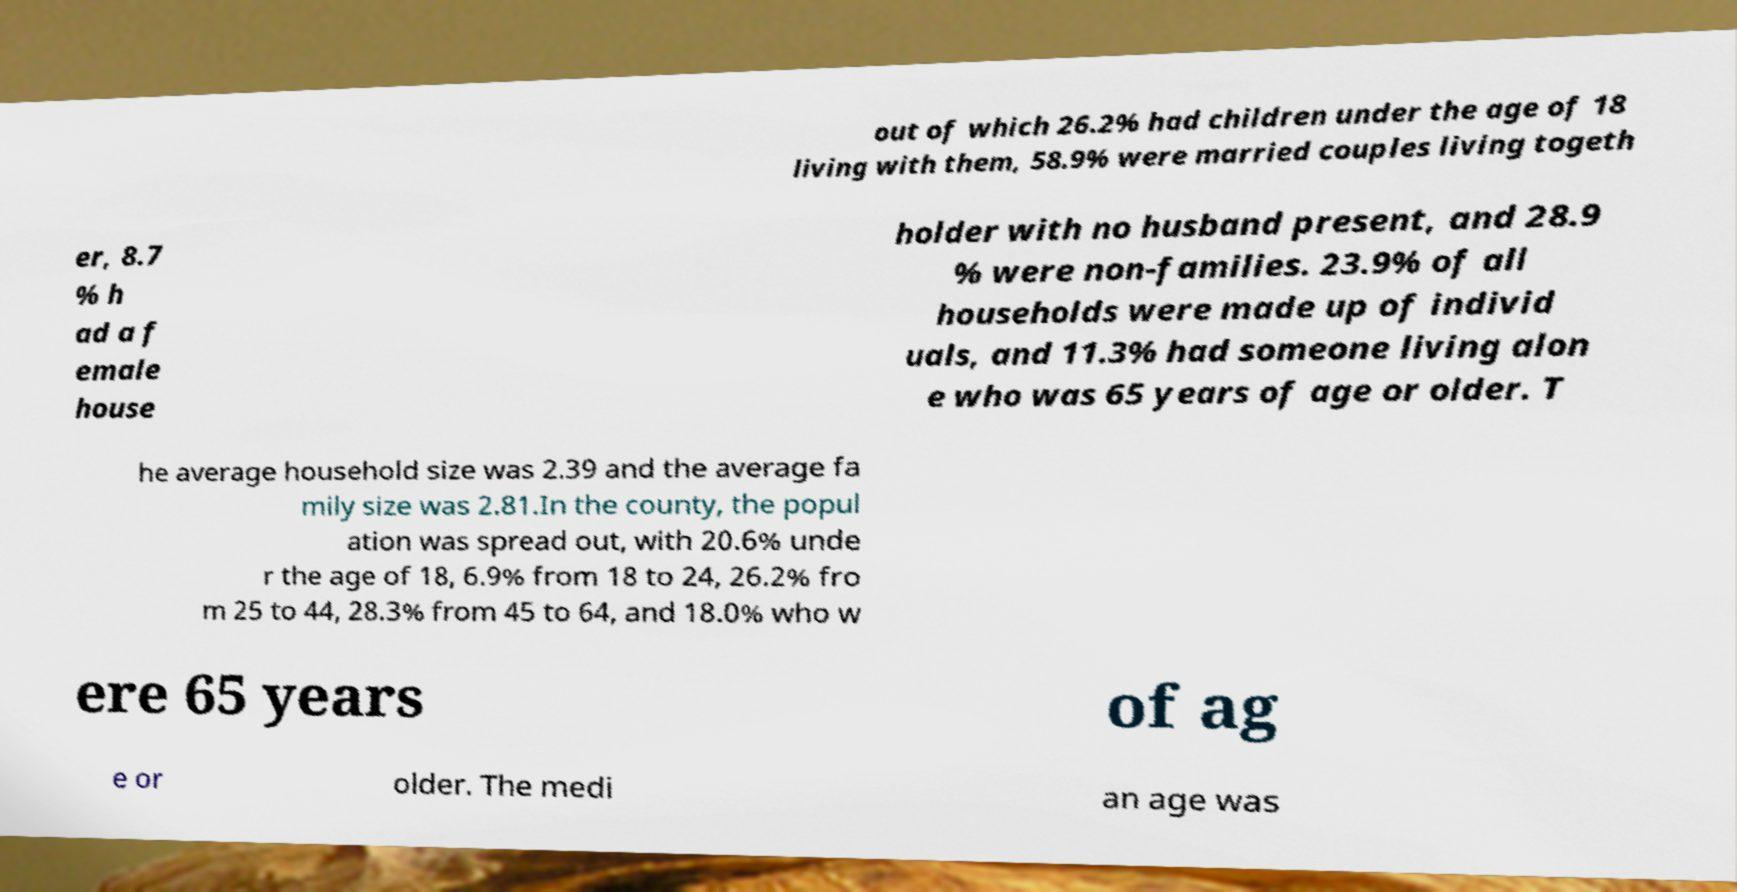Please read and relay the text visible in this image. What does it say? out of which 26.2% had children under the age of 18 living with them, 58.9% were married couples living togeth er, 8.7 % h ad a f emale house holder with no husband present, and 28.9 % were non-families. 23.9% of all households were made up of individ uals, and 11.3% had someone living alon e who was 65 years of age or older. T he average household size was 2.39 and the average fa mily size was 2.81.In the county, the popul ation was spread out, with 20.6% unde r the age of 18, 6.9% from 18 to 24, 26.2% fro m 25 to 44, 28.3% from 45 to 64, and 18.0% who w ere 65 years of ag e or older. The medi an age was 